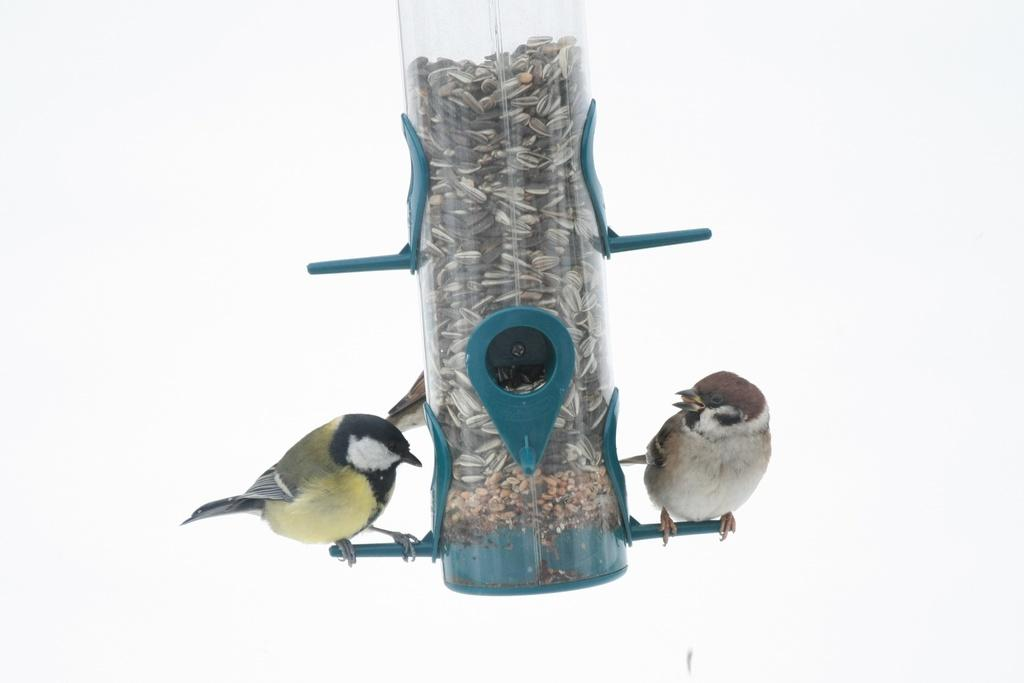What is contained within the object in the image? There are seeds in an object in the image. What can be seen standing on the object? There are two birds standing on the object. What color is the background of the image? The background of the image is white. What type of note is being held by one of the birds in the image? There is no note present in the image; it only features seeds, an object, and two birds. What type of stew is being prepared in the background of the image? There is no stew preparation visible in the image, as the background is white. 